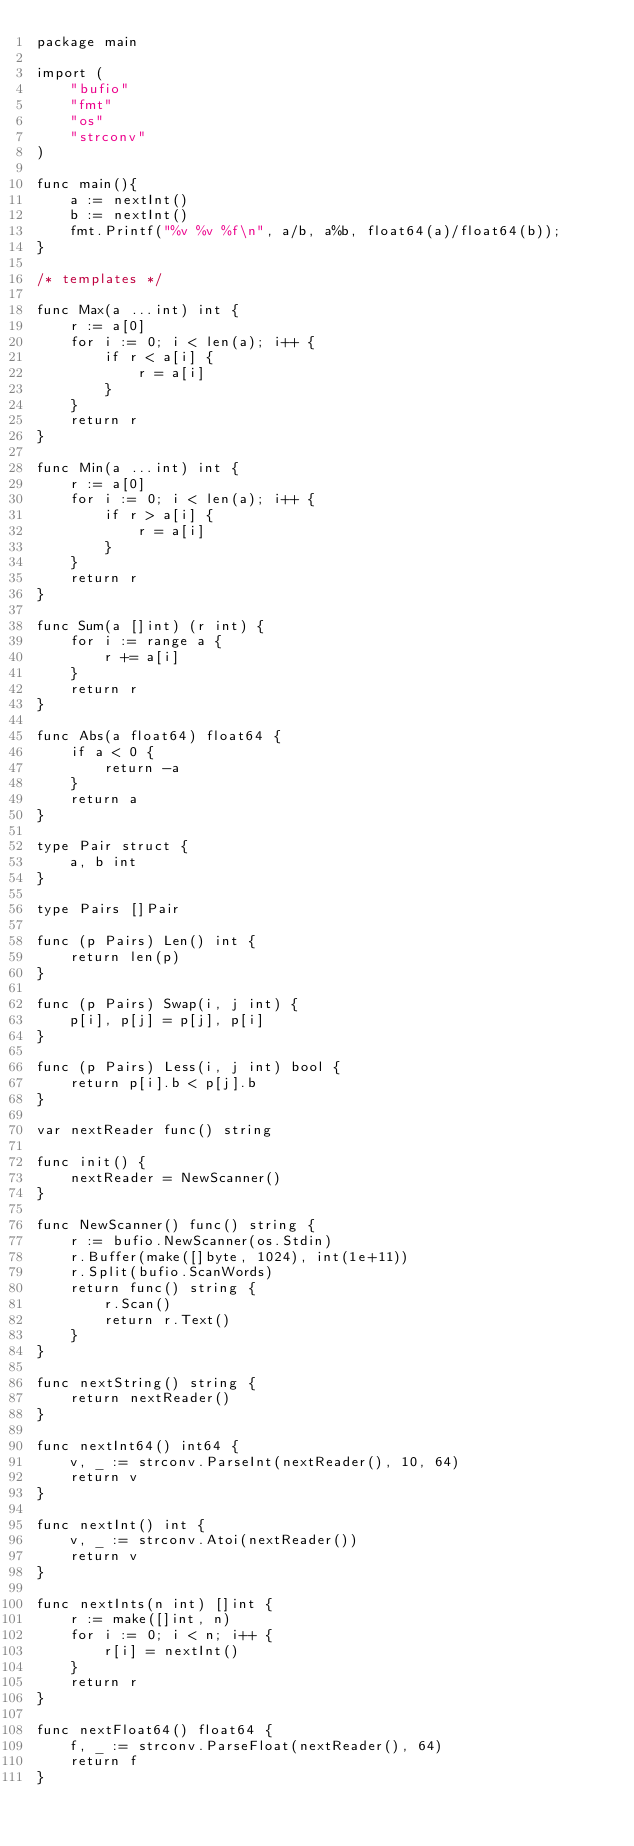Convert code to text. <code><loc_0><loc_0><loc_500><loc_500><_Go_>package main
 
import (
    "bufio"
    "fmt"
    "os"
    "strconv"
)

func main(){
    a := nextInt()
    b := nextInt()
    fmt.Printf("%v %v %f\n", a/b, a%b, float64(a)/float64(b));
}
 
/* templates */
 
func Max(a ...int) int {
    r := a[0]
    for i := 0; i < len(a); i++ {
        if r < a[i] {
            r = a[i]
        }
    }
    return r
}
 
func Min(a ...int) int {
    r := a[0]
    for i := 0; i < len(a); i++ {
        if r > a[i] {
            r = a[i]
        }
    }
    return r
}
 
func Sum(a []int) (r int) {
    for i := range a {
        r += a[i]
    }
    return r
}
 
func Abs(a float64) float64 {
    if a < 0 {
        return -a
    }
    return a
}
 
type Pair struct {
    a, b int
}
 
type Pairs []Pair
 
func (p Pairs) Len() int {
    return len(p)
}
 
func (p Pairs) Swap(i, j int) {
    p[i], p[j] = p[j], p[i]
}
 
func (p Pairs) Less(i, j int) bool {
    return p[i].b < p[j].b
}
 
var nextReader func() string
 
func init() {
    nextReader = NewScanner()
}
 
func NewScanner() func() string {
    r := bufio.NewScanner(os.Stdin)
    r.Buffer(make([]byte, 1024), int(1e+11))
    r.Split(bufio.ScanWords)
    return func() string {
        r.Scan()
        return r.Text()
    }
}
 
func nextString() string {
    return nextReader()
}
 
func nextInt64() int64 {
    v, _ := strconv.ParseInt(nextReader(), 10, 64)
    return v
}
 
func nextInt() int {
    v, _ := strconv.Atoi(nextReader())
    return v
}
 
func nextInts(n int) []int {
    r := make([]int, n)
    for i := 0; i < n; i++ {
        r[i] = nextInt()
    }
    return r
}
 
func nextFloat64() float64 {
    f, _ := strconv.ParseFloat(nextReader(), 64)
    return f
}
</code> 